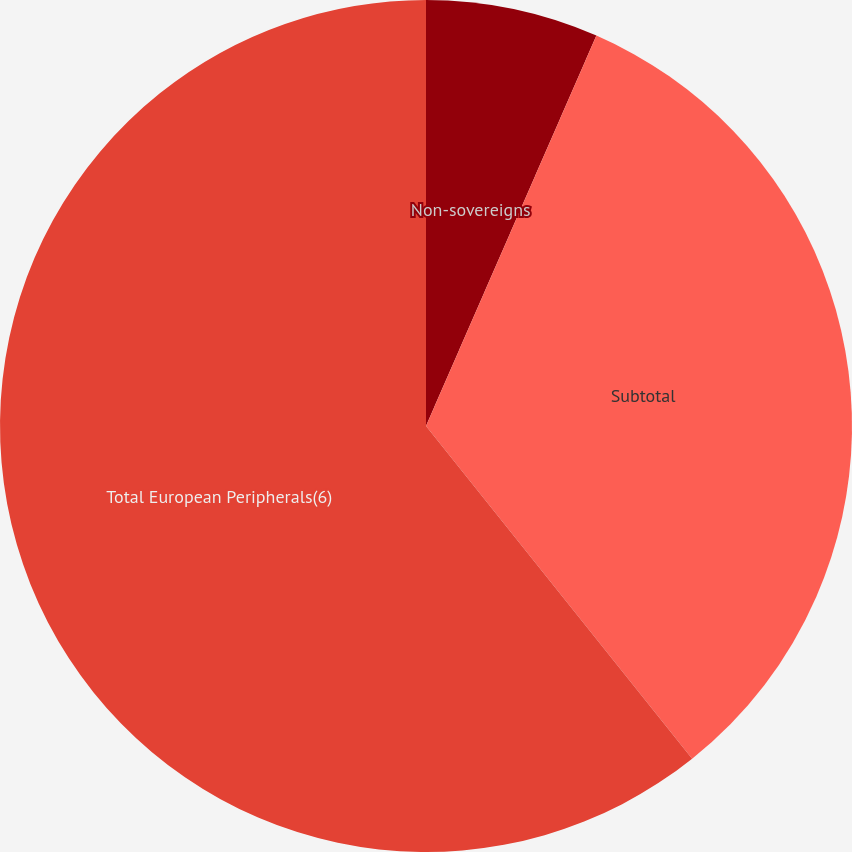Convert chart. <chart><loc_0><loc_0><loc_500><loc_500><pie_chart><fcel>Non-sovereigns<fcel>Subtotal<fcel>Total European Peripherals(6)<nl><fcel>6.55%<fcel>32.71%<fcel>60.74%<nl></chart> 